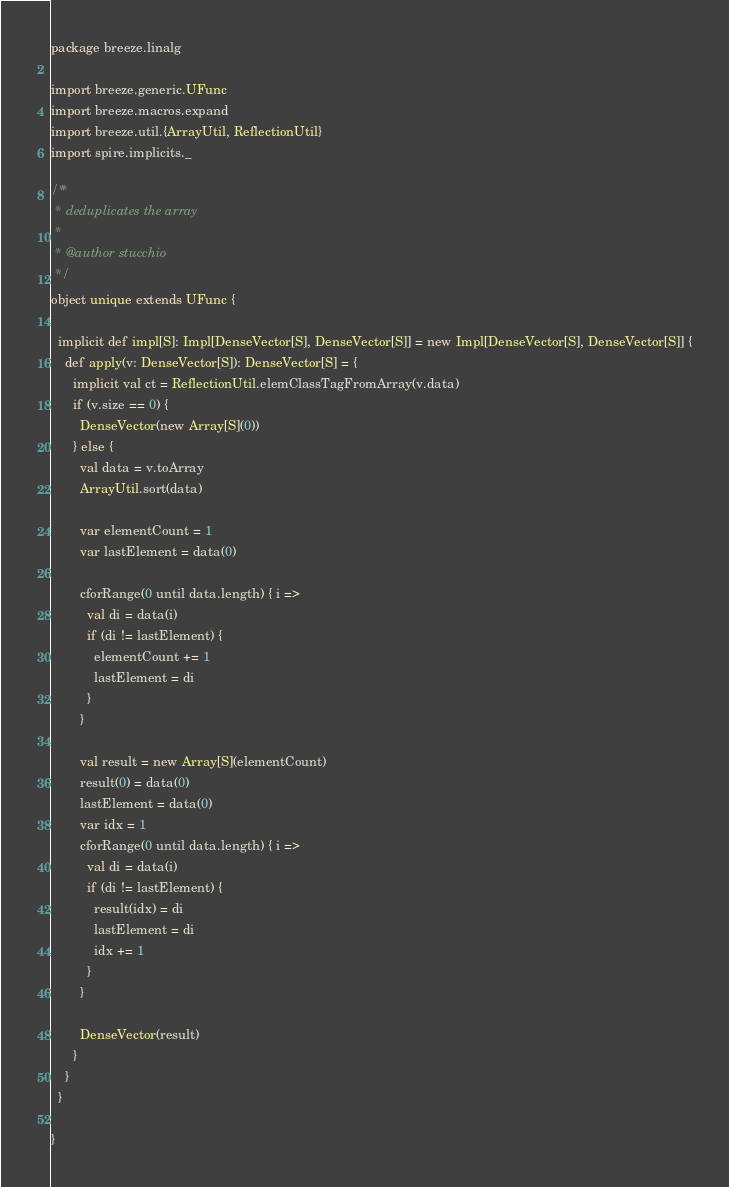<code> <loc_0><loc_0><loc_500><loc_500><_Scala_>package breeze.linalg

import breeze.generic.UFunc
import breeze.macros.expand
import breeze.util.{ArrayUtil, ReflectionUtil}
import spire.implicits._

/**
 * deduplicates the array
 *
 * @author stucchio
 */
object unique extends UFunc {

  implicit def impl[S]: Impl[DenseVector[S], DenseVector[S]] = new Impl[DenseVector[S], DenseVector[S]] {
    def apply(v: DenseVector[S]): DenseVector[S] = {
      implicit val ct = ReflectionUtil.elemClassTagFromArray(v.data)
      if (v.size == 0) {
        DenseVector(new Array[S](0))
      } else {
        val data = v.toArray
        ArrayUtil.sort(data)

        var elementCount = 1
        var lastElement = data(0)

        cforRange(0 until data.length) { i =>
          val di = data(i)
          if (di != lastElement) {
            elementCount += 1
            lastElement = di
          }
        }

        val result = new Array[S](elementCount)
        result(0) = data(0)
        lastElement = data(0)
        var idx = 1
        cforRange(0 until data.length) { i =>
          val di = data(i)
          if (di != lastElement) {
            result(idx) = di
            lastElement = di
            idx += 1
          }
        }

        DenseVector(result)
      }
    }
  }

}
</code> 